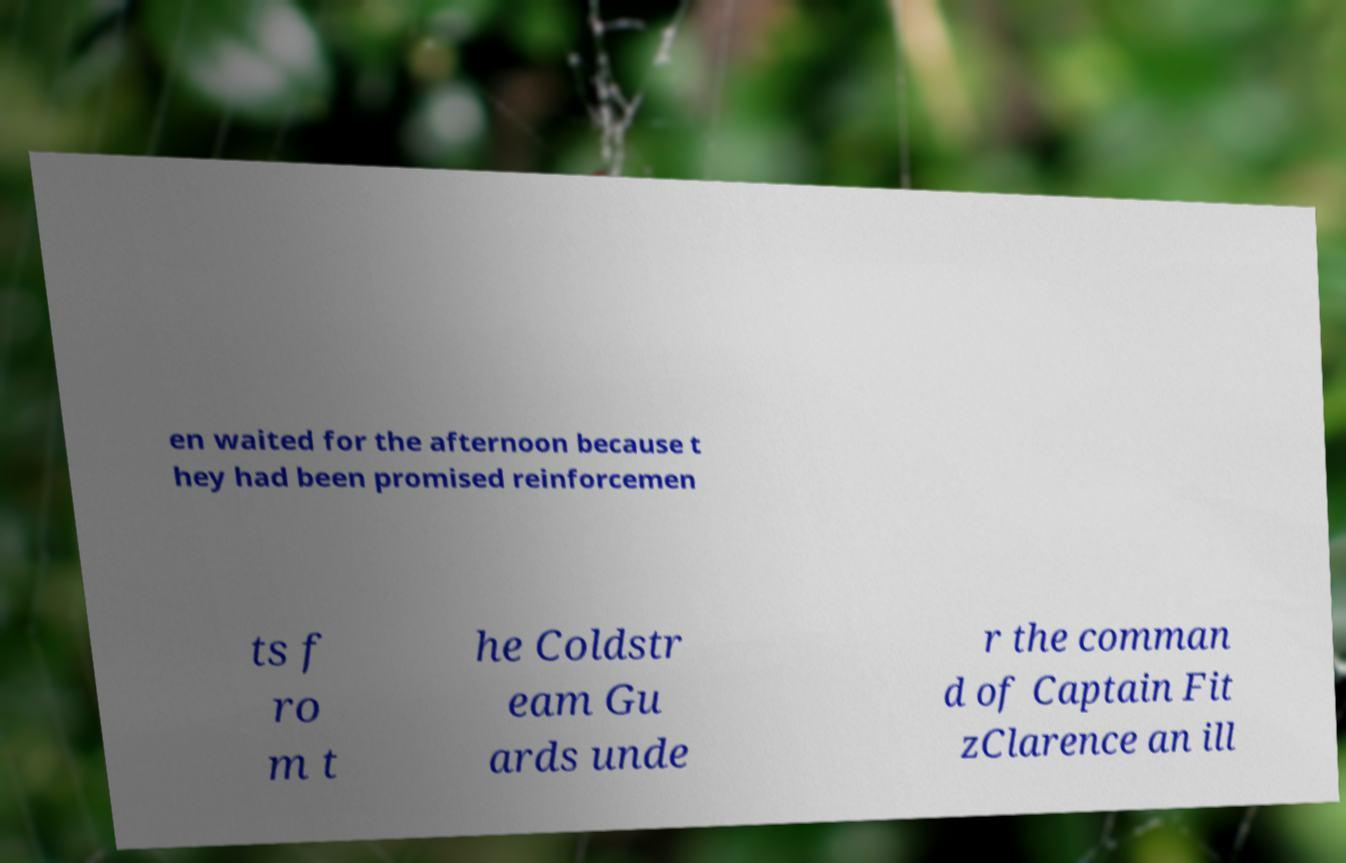Please identify and transcribe the text found in this image. en waited for the afternoon because t hey had been promised reinforcemen ts f ro m t he Coldstr eam Gu ards unde r the comman d of Captain Fit zClarence an ill 